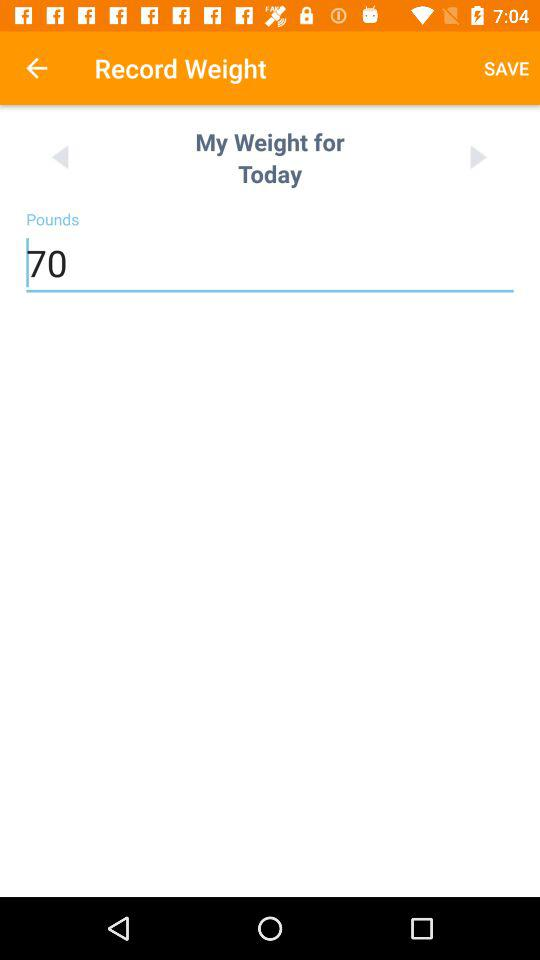What will my weight be tomorrow?
When the provided information is insufficient, respond with <no answer>. <no answer> 